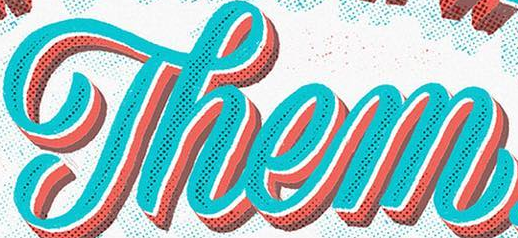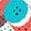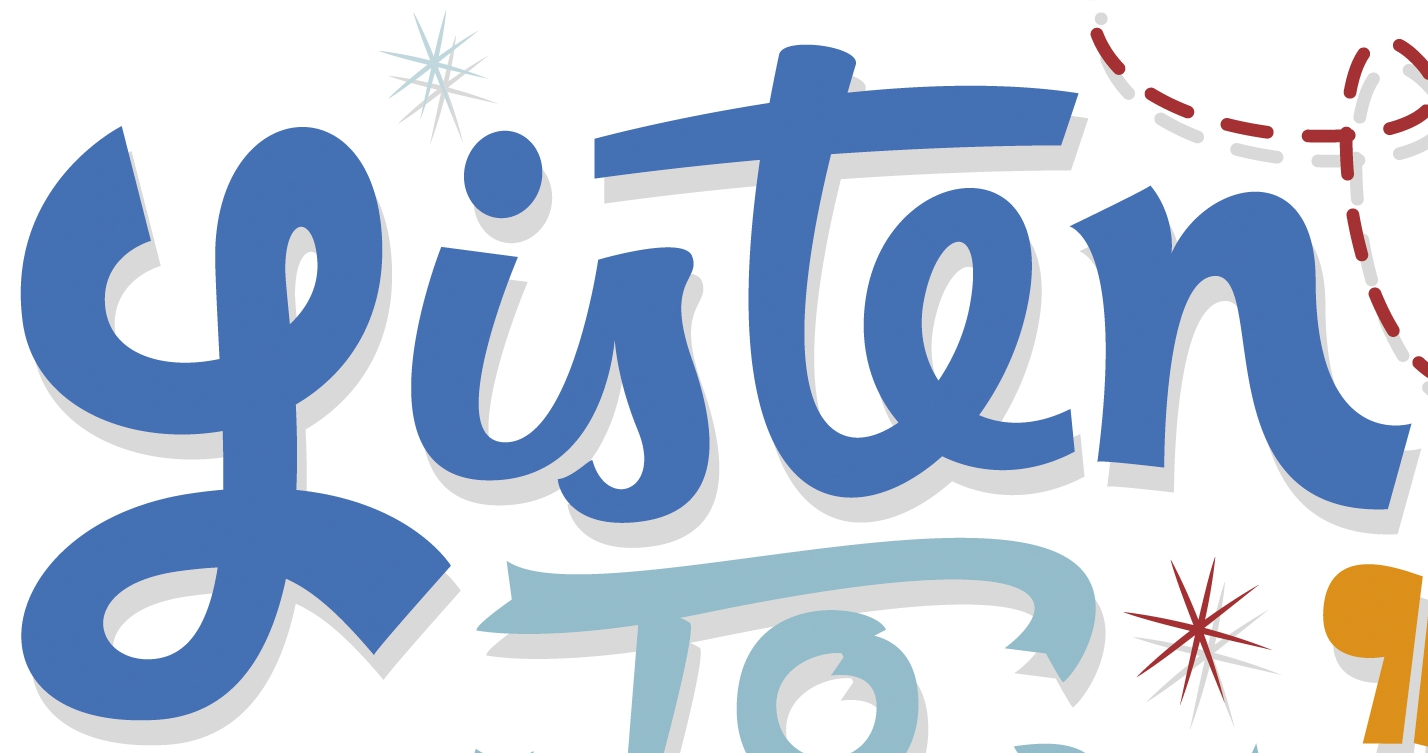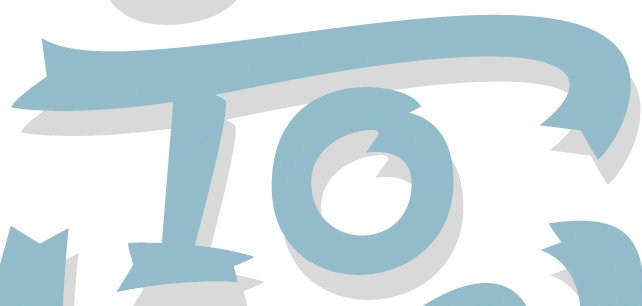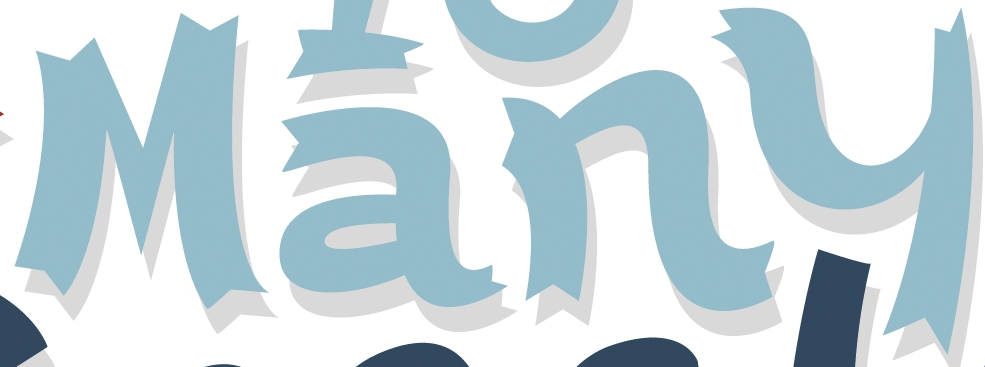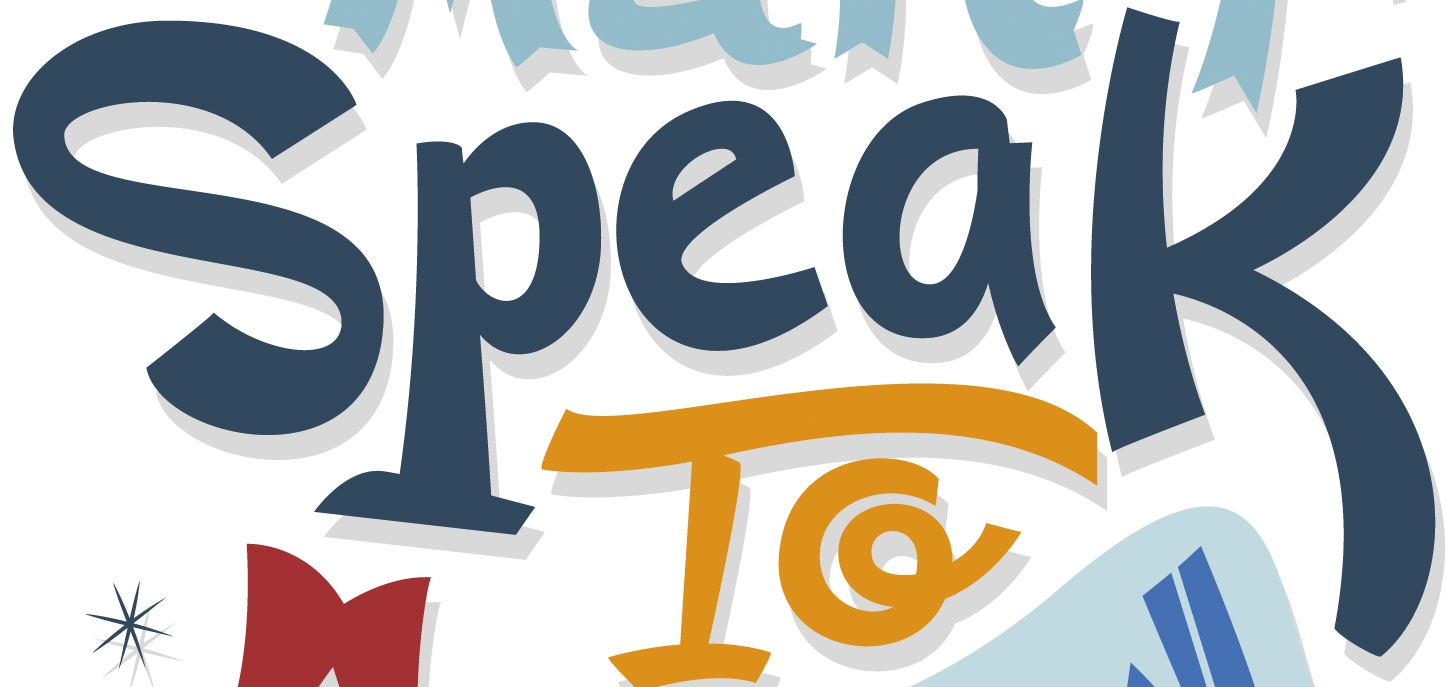Read the text from these images in sequence, separated by a semicolon. Them; .; Listen; To; Many; Speak 